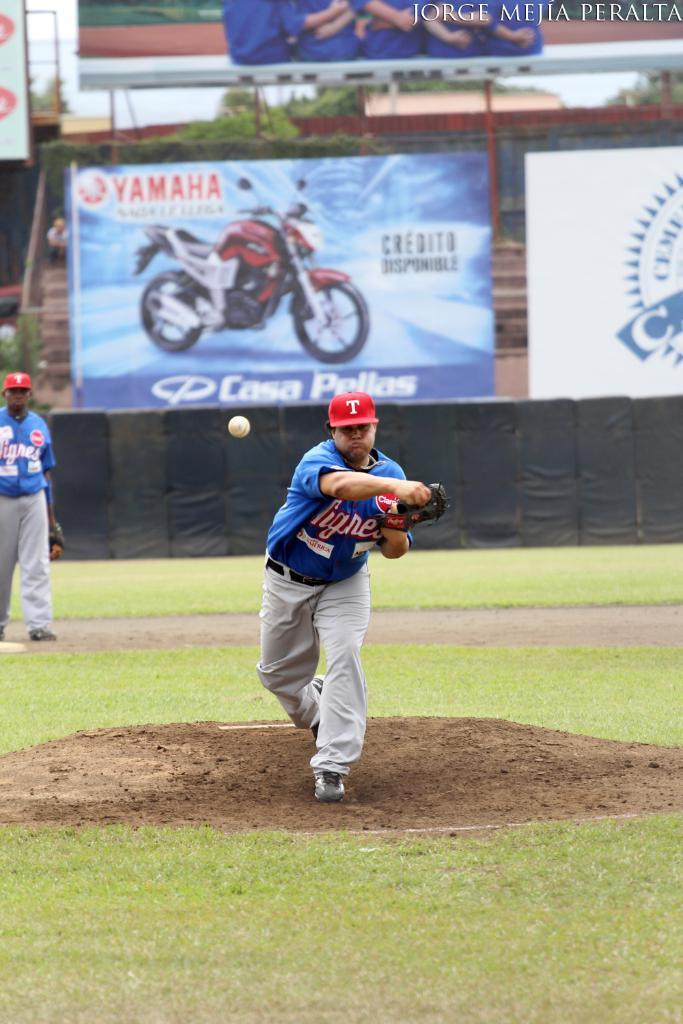<image>
Render a clear and concise summary of the photo. A pitcher throws a ball with a Yamaha motorcycle ad in the background 